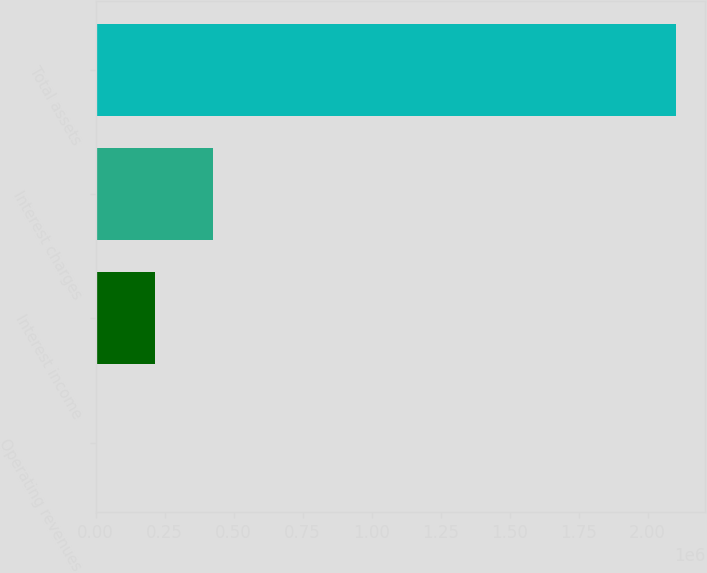<chart> <loc_0><loc_0><loc_500><loc_500><bar_chart><fcel>Operating revenues<fcel>Interest income<fcel>Interest charges<fcel>Total assets<nl><fcel>4111<fcel>214029<fcel>423947<fcel>2.10329e+06<nl></chart> 